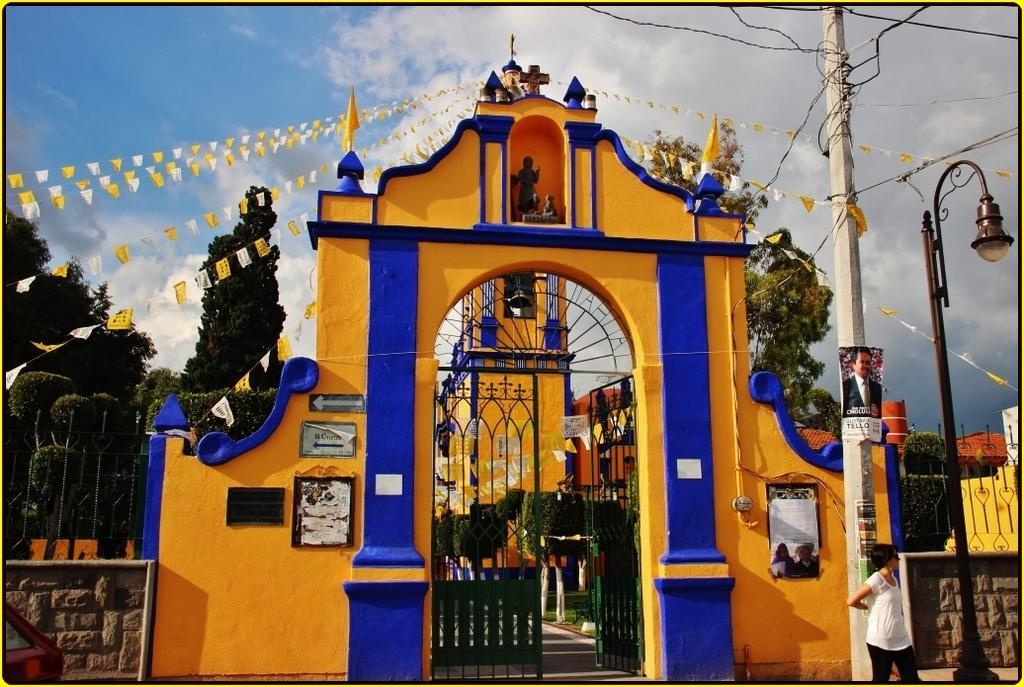Can you describe this image briefly? In this image, we can see a wall and there is a gate, there is a pole, we can see there is a light, we can see some trees, at the top there is a blue sky and there are some clouds. 